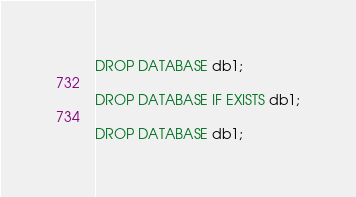<code> <loc_0><loc_0><loc_500><loc_500><_SQL_>
DROP DATABASE db1;

DROP DATABASE IF EXISTS db1;

DROP DATABASE db1;
</code> 